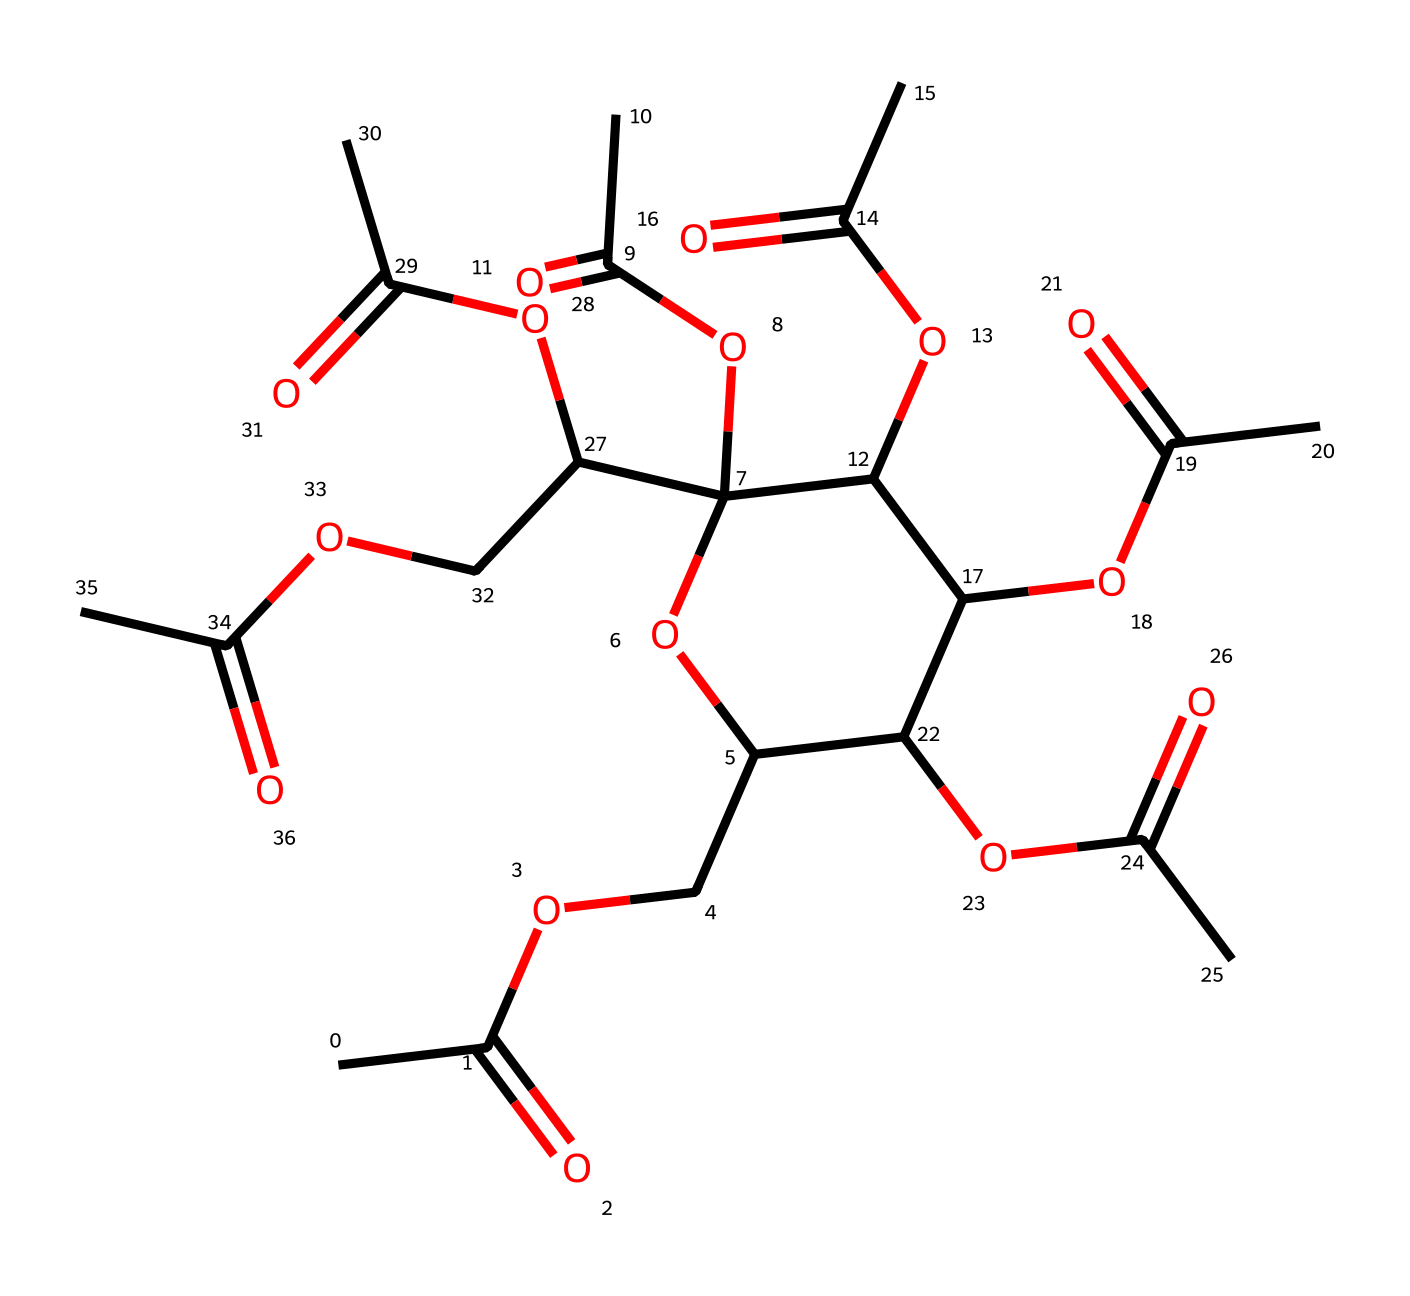What is the name of this chemical? The SMILES representation indicates that the chemical is cellulose acetate, as it contains multiple acetate (acetyl) groups attached to a cellulose backbone.
Answer: cellulose acetate How many carbon atoms are present in this chemical? By analyzing the SMILES representation, we can count the number of carbon atoms (C). There are a total of 12 carbon atoms in cellulose acetate.
Answer: 12 What type of compound is cellulose acetate? The structure contains ester functional groups formed by the reaction of acetic acid with cellulose, which classifies it as an ester.
Answer: ester How many ester groups are present in this chemical? Examining the structure reveals that there are five acetate groups attached to the cellulose backbone, indicating five ester linkages.
Answer: 5 Does cellulose acetate contain an ether functional group? Yes, the presence of -O- bonds in the structure indicates that cellulose acetate also has ether functional groups within its structure due to the ether linkages between the cellulose units.
Answer: yes What functional groups can be identified in cellulose acetate? The structure clearly shows both acetate groups (ester functional groups) and ether linkages (-O-), combining the characteristics of esters and ethers.
Answer: ester and ether 